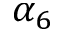Convert formula to latex. <formula><loc_0><loc_0><loc_500><loc_500>\alpha _ { 6 }</formula> 